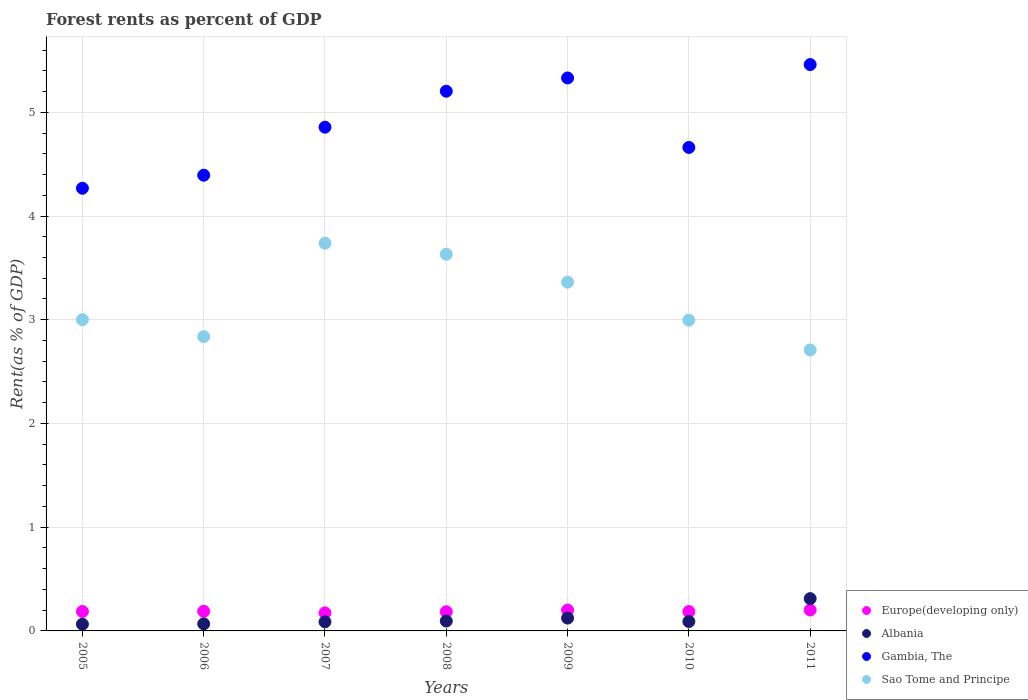How many different coloured dotlines are there?
Offer a terse response. 4. What is the forest rent in Gambia, The in 2007?
Give a very brief answer. 4.86. Across all years, what is the maximum forest rent in Sao Tome and Principe?
Give a very brief answer. 3.74. Across all years, what is the minimum forest rent in Gambia, The?
Make the answer very short. 4.27. What is the total forest rent in Europe(developing only) in the graph?
Your response must be concise. 1.32. What is the difference between the forest rent in Gambia, The in 2008 and that in 2011?
Your response must be concise. -0.26. What is the difference between the forest rent in Gambia, The in 2007 and the forest rent in Sao Tome and Principe in 2008?
Give a very brief answer. 1.22. What is the average forest rent in Sao Tome and Principe per year?
Provide a succinct answer. 3.18. In the year 2010, what is the difference between the forest rent in Gambia, The and forest rent in Sao Tome and Principe?
Keep it short and to the point. 1.67. What is the ratio of the forest rent in Europe(developing only) in 2007 to that in 2008?
Make the answer very short. 0.94. What is the difference between the highest and the second highest forest rent in Europe(developing only)?
Your response must be concise. 0. What is the difference between the highest and the lowest forest rent in Gambia, The?
Provide a short and direct response. 1.19. Is the sum of the forest rent in Europe(developing only) in 2005 and 2010 greater than the maximum forest rent in Sao Tome and Principe across all years?
Offer a terse response. No. Is it the case that in every year, the sum of the forest rent in Albania and forest rent in Europe(developing only)  is greater than the sum of forest rent in Gambia, The and forest rent in Sao Tome and Principe?
Keep it short and to the point. No. Is it the case that in every year, the sum of the forest rent in Gambia, The and forest rent in Europe(developing only)  is greater than the forest rent in Sao Tome and Principe?
Keep it short and to the point. Yes. Does the forest rent in Sao Tome and Principe monotonically increase over the years?
Keep it short and to the point. No. Is the forest rent in Sao Tome and Principe strictly less than the forest rent in Europe(developing only) over the years?
Provide a succinct answer. No. How many dotlines are there?
Make the answer very short. 4. How many years are there in the graph?
Give a very brief answer. 7. Where does the legend appear in the graph?
Give a very brief answer. Bottom right. How many legend labels are there?
Make the answer very short. 4. How are the legend labels stacked?
Make the answer very short. Vertical. What is the title of the graph?
Provide a succinct answer. Forest rents as percent of GDP. What is the label or title of the X-axis?
Provide a short and direct response. Years. What is the label or title of the Y-axis?
Offer a very short reply. Rent(as % of GDP). What is the Rent(as % of GDP) of Europe(developing only) in 2005?
Provide a succinct answer. 0.19. What is the Rent(as % of GDP) of Albania in 2005?
Offer a very short reply. 0.06. What is the Rent(as % of GDP) of Gambia, The in 2005?
Ensure brevity in your answer.  4.27. What is the Rent(as % of GDP) of Sao Tome and Principe in 2005?
Provide a succinct answer. 3. What is the Rent(as % of GDP) in Europe(developing only) in 2006?
Give a very brief answer. 0.19. What is the Rent(as % of GDP) in Albania in 2006?
Ensure brevity in your answer.  0.07. What is the Rent(as % of GDP) of Gambia, The in 2006?
Give a very brief answer. 4.39. What is the Rent(as % of GDP) in Sao Tome and Principe in 2006?
Your answer should be compact. 2.84. What is the Rent(as % of GDP) of Europe(developing only) in 2007?
Provide a short and direct response. 0.17. What is the Rent(as % of GDP) of Albania in 2007?
Make the answer very short. 0.09. What is the Rent(as % of GDP) of Gambia, The in 2007?
Ensure brevity in your answer.  4.86. What is the Rent(as % of GDP) in Sao Tome and Principe in 2007?
Your answer should be compact. 3.74. What is the Rent(as % of GDP) of Europe(developing only) in 2008?
Keep it short and to the point. 0.18. What is the Rent(as % of GDP) in Albania in 2008?
Keep it short and to the point. 0.1. What is the Rent(as % of GDP) in Gambia, The in 2008?
Your response must be concise. 5.2. What is the Rent(as % of GDP) in Sao Tome and Principe in 2008?
Your answer should be very brief. 3.63. What is the Rent(as % of GDP) in Europe(developing only) in 2009?
Ensure brevity in your answer.  0.2. What is the Rent(as % of GDP) of Albania in 2009?
Provide a short and direct response. 0.12. What is the Rent(as % of GDP) of Gambia, The in 2009?
Provide a succinct answer. 5.33. What is the Rent(as % of GDP) of Sao Tome and Principe in 2009?
Make the answer very short. 3.36. What is the Rent(as % of GDP) in Europe(developing only) in 2010?
Provide a succinct answer. 0.19. What is the Rent(as % of GDP) of Albania in 2010?
Provide a short and direct response. 0.09. What is the Rent(as % of GDP) in Gambia, The in 2010?
Offer a very short reply. 4.66. What is the Rent(as % of GDP) of Sao Tome and Principe in 2010?
Keep it short and to the point. 3. What is the Rent(as % of GDP) in Europe(developing only) in 2011?
Your answer should be very brief. 0.2. What is the Rent(as % of GDP) in Albania in 2011?
Offer a very short reply. 0.31. What is the Rent(as % of GDP) of Gambia, The in 2011?
Your answer should be compact. 5.46. What is the Rent(as % of GDP) of Sao Tome and Principe in 2011?
Your answer should be very brief. 2.71. Across all years, what is the maximum Rent(as % of GDP) of Europe(developing only)?
Offer a terse response. 0.2. Across all years, what is the maximum Rent(as % of GDP) in Albania?
Offer a very short reply. 0.31. Across all years, what is the maximum Rent(as % of GDP) of Gambia, The?
Ensure brevity in your answer.  5.46. Across all years, what is the maximum Rent(as % of GDP) of Sao Tome and Principe?
Make the answer very short. 3.74. Across all years, what is the minimum Rent(as % of GDP) of Europe(developing only)?
Offer a terse response. 0.17. Across all years, what is the minimum Rent(as % of GDP) in Albania?
Offer a terse response. 0.06. Across all years, what is the minimum Rent(as % of GDP) in Gambia, The?
Provide a succinct answer. 4.27. Across all years, what is the minimum Rent(as % of GDP) in Sao Tome and Principe?
Provide a short and direct response. 2.71. What is the total Rent(as % of GDP) in Europe(developing only) in the graph?
Your answer should be compact. 1.32. What is the total Rent(as % of GDP) of Albania in the graph?
Offer a very short reply. 0.84. What is the total Rent(as % of GDP) in Gambia, The in the graph?
Your answer should be very brief. 34.17. What is the total Rent(as % of GDP) in Sao Tome and Principe in the graph?
Keep it short and to the point. 22.27. What is the difference between the Rent(as % of GDP) of Europe(developing only) in 2005 and that in 2006?
Offer a terse response. -0. What is the difference between the Rent(as % of GDP) of Albania in 2005 and that in 2006?
Ensure brevity in your answer.  -0. What is the difference between the Rent(as % of GDP) of Gambia, The in 2005 and that in 2006?
Make the answer very short. -0.13. What is the difference between the Rent(as % of GDP) of Sao Tome and Principe in 2005 and that in 2006?
Ensure brevity in your answer.  0.16. What is the difference between the Rent(as % of GDP) in Europe(developing only) in 2005 and that in 2007?
Provide a short and direct response. 0.01. What is the difference between the Rent(as % of GDP) in Albania in 2005 and that in 2007?
Make the answer very short. -0.02. What is the difference between the Rent(as % of GDP) in Gambia, The in 2005 and that in 2007?
Ensure brevity in your answer.  -0.59. What is the difference between the Rent(as % of GDP) in Sao Tome and Principe in 2005 and that in 2007?
Provide a succinct answer. -0.74. What is the difference between the Rent(as % of GDP) in Europe(developing only) in 2005 and that in 2008?
Your response must be concise. 0. What is the difference between the Rent(as % of GDP) of Albania in 2005 and that in 2008?
Your answer should be compact. -0.03. What is the difference between the Rent(as % of GDP) of Gambia, The in 2005 and that in 2008?
Make the answer very short. -0.94. What is the difference between the Rent(as % of GDP) of Sao Tome and Principe in 2005 and that in 2008?
Your answer should be compact. -0.63. What is the difference between the Rent(as % of GDP) of Europe(developing only) in 2005 and that in 2009?
Offer a very short reply. -0.01. What is the difference between the Rent(as % of GDP) of Albania in 2005 and that in 2009?
Provide a succinct answer. -0.06. What is the difference between the Rent(as % of GDP) of Gambia, The in 2005 and that in 2009?
Your answer should be very brief. -1.06. What is the difference between the Rent(as % of GDP) in Sao Tome and Principe in 2005 and that in 2009?
Your answer should be very brief. -0.36. What is the difference between the Rent(as % of GDP) in Europe(developing only) in 2005 and that in 2010?
Your response must be concise. 0. What is the difference between the Rent(as % of GDP) of Albania in 2005 and that in 2010?
Provide a succinct answer. -0.03. What is the difference between the Rent(as % of GDP) in Gambia, The in 2005 and that in 2010?
Provide a short and direct response. -0.39. What is the difference between the Rent(as % of GDP) in Sao Tome and Principe in 2005 and that in 2010?
Give a very brief answer. 0.01. What is the difference between the Rent(as % of GDP) of Europe(developing only) in 2005 and that in 2011?
Provide a short and direct response. -0.01. What is the difference between the Rent(as % of GDP) in Albania in 2005 and that in 2011?
Make the answer very short. -0.25. What is the difference between the Rent(as % of GDP) of Gambia, The in 2005 and that in 2011?
Provide a short and direct response. -1.19. What is the difference between the Rent(as % of GDP) in Sao Tome and Principe in 2005 and that in 2011?
Offer a terse response. 0.29. What is the difference between the Rent(as % of GDP) in Europe(developing only) in 2006 and that in 2007?
Your answer should be very brief. 0.02. What is the difference between the Rent(as % of GDP) of Albania in 2006 and that in 2007?
Give a very brief answer. -0.02. What is the difference between the Rent(as % of GDP) in Gambia, The in 2006 and that in 2007?
Make the answer very short. -0.46. What is the difference between the Rent(as % of GDP) in Sao Tome and Principe in 2006 and that in 2007?
Make the answer very short. -0.9. What is the difference between the Rent(as % of GDP) in Europe(developing only) in 2006 and that in 2008?
Offer a terse response. 0. What is the difference between the Rent(as % of GDP) in Albania in 2006 and that in 2008?
Give a very brief answer. -0.03. What is the difference between the Rent(as % of GDP) in Gambia, The in 2006 and that in 2008?
Ensure brevity in your answer.  -0.81. What is the difference between the Rent(as % of GDP) of Sao Tome and Principe in 2006 and that in 2008?
Offer a very short reply. -0.79. What is the difference between the Rent(as % of GDP) in Europe(developing only) in 2006 and that in 2009?
Offer a terse response. -0.01. What is the difference between the Rent(as % of GDP) in Albania in 2006 and that in 2009?
Offer a terse response. -0.06. What is the difference between the Rent(as % of GDP) in Gambia, The in 2006 and that in 2009?
Offer a terse response. -0.94. What is the difference between the Rent(as % of GDP) in Sao Tome and Principe in 2006 and that in 2009?
Your answer should be very brief. -0.52. What is the difference between the Rent(as % of GDP) in Europe(developing only) in 2006 and that in 2010?
Ensure brevity in your answer.  0. What is the difference between the Rent(as % of GDP) of Albania in 2006 and that in 2010?
Ensure brevity in your answer.  -0.02. What is the difference between the Rent(as % of GDP) of Gambia, The in 2006 and that in 2010?
Your answer should be very brief. -0.27. What is the difference between the Rent(as % of GDP) of Sao Tome and Principe in 2006 and that in 2010?
Your answer should be compact. -0.16. What is the difference between the Rent(as % of GDP) of Europe(developing only) in 2006 and that in 2011?
Keep it short and to the point. -0.01. What is the difference between the Rent(as % of GDP) of Albania in 2006 and that in 2011?
Your answer should be compact. -0.24. What is the difference between the Rent(as % of GDP) in Gambia, The in 2006 and that in 2011?
Your response must be concise. -1.07. What is the difference between the Rent(as % of GDP) in Sao Tome and Principe in 2006 and that in 2011?
Provide a short and direct response. 0.13. What is the difference between the Rent(as % of GDP) in Europe(developing only) in 2007 and that in 2008?
Offer a terse response. -0.01. What is the difference between the Rent(as % of GDP) of Albania in 2007 and that in 2008?
Give a very brief answer. -0.01. What is the difference between the Rent(as % of GDP) in Gambia, The in 2007 and that in 2008?
Give a very brief answer. -0.35. What is the difference between the Rent(as % of GDP) of Sao Tome and Principe in 2007 and that in 2008?
Your response must be concise. 0.11. What is the difference between the Rent(as % of GDP) of Europe(developing only) in 2007 and that in 2009?
Offer a very short reply. -0.03. What is the difference between the Rent(as % of GDP) in Albania in 2007 and that in 2009?
Your answer should be very brief. -0.04. What is the difference between the Rent(as % of GDP) in Gambia, The in 2007 and that in 2009?
Make the answer very short. -0.47. What is the difference between the Rent(as % of GDP) in Sao Tome and Principe in 2007 and that in 2009?
Give a very brief answer. 0.38. What is the difference between the Rent(as % of GDP) in Europe(developing only) in 2007 and that in 2010?
Offer a very short reply. -0.01. What is the difference between the Rent(as % of GDP) in Albania in 2007 and that in 2010?
Give a very brief answer. -0. What is the difference between the Rent(as % of GDP) of Gambia, The in 2007 and that in 2010?
Offer a very short reply. 0.2. What is the difference between the Rent(as % of GDP) of Sao Tome and Principe in 2007 and that in 2010?
Provide a short and direct response. 0.74. What is the difference between the Rent(as % of GDP) in Europe(developing only) in 2007 and that in 2011?
Make the answer very short. -0.03. What is the difference between the Rent(as % of GDP) of Albania in 2007 and that in 2011?
Offer a very short reply. -0.22. What is the difference between the Rent(as % of GDP) of Gambia, The in 2007 and that in 2011?
Offer a terse response. -0.6. What is the difference between the Rent(as % of GDP) of Sao Tome and Principe in 2007 and that in 2011?
Give a very brief answer. 1.03. What is the difference between the Rent(as % of GDP) in Europe(developing only) in 2008 and that in 2009?
Offer a very short reply. -0.02. What is the difference between the Rent(as % of GDP) in Albania in 2008 and that in 2009?
Give a very brief answer. -0.03. What is the difference between the Rent(as % of GDP) of Gambia, The in 2008 and that in 2009?
Make the answer very short. -0.13. What is the difference between the Rent(as % of GDP) in Sao Tome and Principe in 2008 and that in 2009?
Offer a terse response. 0.27. What is the difference between the Rent(as % of GDP) in Europe(developing only) in 2008 and that in 2010?
Give a very brief answer. -0. What is the difference between the Rent(as % of GDP) of Albania in 2008 and that in 2010?
Offer a very short reply. 0. What is the difference between the Rent(as % of GDP) of Gambia, The in 2008 and that in 2010?
Your answer should be very brief. 0.54. What is the difference between the Rent(as % of GDP) of Sao Tome and Principe in 2008 and that in 2010?
Keep it short and to the point. 0.64. What is the difference between the Rent(as % of GDP) of Europe(developing only) in 2008 and that in 2011?
Provide a short and direct response. -0.02. What is the difference between the Rent(as % of GDP) in Albania in 2008 and that in 2011?
Give a very brief answer. -0.22. What is the difference between the Rent(as % of GDP) in Gambia, The in 2008 and that in 2011?
Provide a short and direct response. -0.26. What is the difference between the Rent(as % of GDP) of Sao Tome and Principe in 2008 and that in 2011?
Keep it short and to the point. 0.92. What is the difference between the Rent(as % of GDP) of Europe(developing only) in 2009 and that in 2010?
Keep it short and to the point. 0.01. What is the difference between the Rent(as % of GDP) of Albania in 2009 and that in 2010?
Your answer should be compact. 0.03. What is the difference between the Rent(as % of GDP) in Gambia, The in 2009 and that in 2010?
Ensure brevity in your answer.  0.67. What is the difference between the Rent(as % of GDP) of Sao Tome and Principe in 2009 and that in 2010?
Offer a terse response. 0.37. What is the difference between the Rent(as % of GDP) of Europe(developing only) in 2009 and that in 2011?
Make the answer very short. -0. What is the difference between the Rent(as % of GDP) of Albania in 2009 and that in 2011?
Your answer should be compact. -0.19. What is the difference between the Rent(as % of GDP) in Gambia, The in 2009 and that in 2011?
Your answer should be compact. -0.13. What is the difference between the Rent(as % of GDP) in Sao Tome and Principe in 2009 and that in 2011?
Offer a very short reply. 0.65. What is the difference between the Rent(as % of GDP) in Europe(developing only) in 2010 and that in 2011?
Your answer should be very brief. -0.02. What is the difference between the Rent(as % of GDP) of Albania in 2010 and that in 2011?
Make the answer very short. -0.22. What is the difference between the Rent(as % of GDP) in Gambia, The in 2010 and that in 2011?
Offer a terse response. -0.8. What is the difference between the Rent(as % of GDP) of Sao Tome and Principe in 2010 and that in 2011?
Provide a succinct answer. 0.29. What is the difference between the Rent(as % of GDP) of Europe(developing only) in 2005 and the Rent(as % of GDP) of Albania in 2006?
Your answer should be compact. 0.12. What is the difference between the Rent(as % of GDP) of Europe(developing only) in 2005 and the Rent(as % of GDP) of Gambia, The in 2006?
Provide a succinct answer. -4.21. What is the difference between the Rent(as % of GDP) of Europe(developing only) in 2005 and the Rent(as % of GDP) of Sao Tome and Principe in 2006?
Offer a terse response. -2.65. What is the difference between the Rent(as % of GDP) of Albania in 2005 and the Rent(as % of GDP) of Gambia, The in 2006?
Make the answer very short. -4.33. What is the difference between the Rent(as % of GDP) of Albania in 2005 and the Rent(as % of GDP) of Sao Tome and Principe in 2006?
Give a very brief answer. -2.77. What is the difference between the Rent(as % of GDP) of Gambia, The in 2005 and the Rent(as % of GDP) of Sao Tome and Principe in 2006?
Your response must be concise. 1.43. What is the difference between the Rent(as % of GDP) in Europe(developing only) in 2005 and the Rent(as % of GDP) in Albania in 2007?
Your answer should be very brief. 0.1. What is the difference between the Rent(as % of GDP) in Europe(developing only) in 2005 and the Rent(as % of GDP) in Gambia, The in 2007?
Your answer should be very brief. -4.67. What is the difference between the Rent(as % of GDP) in Europe(developing only) in 2005 and the Rent(as % of GDP) in Sao Tome and Principe in 2007?
Ensure brevity in your answer.  -3.55. What is the difference between the Rent(as % of GDP) of Albania in 2005 and the Rent(as % of GDP) of Gambia, The in 2007?
Provide a succinct answer. -4.79. What is the difference between the Rent(as % of GDP) of Albania in 2005 and the Rent(as % of GDP) of Sao Tome and Principe in 2007?
Your response must be concise. -3.67. What is the difference between the Rent(as % of GDP) in Gambia, The in 2005 and the Rent(as % of GDP) in Sao Tome and Principe in 2007?
Make the answer very short. 0.53. What is the difference between the Rent(as % of GDP) in Europe(developing only) in 2005 and the Rent(as % of GDP) in Albania in 2008?
Make the answer very short. 0.09. What is the difference between the Rent(as % of GDP) of Europe(developing only) in 2005 and the Rent(as % of GDP) of Gambia, The in 2008?
Offer a very short reply. -5.02. What is the difference between the Rent(as % of GDP) of Europe(developing only) in 2005 and the Rent(as % of GDP) of Sao Tome and Principe in 2008?
Offer a very short reply. -3.44. What is the difference between the Rent(as % of GDP) in Albania in 2005 and the Rent(as % of GDP) in Gambia, The in 2008?
Your answer should be compact. -5.14. What is the difference between the Rent(as % of GDP) of Albania in 2005 and the Rent(as % of GDP) of Sao Tome and Principe in 2008?
Make the answer very short. -3.57. What is the difference between the Rent(as % of GDP) in Gambia, The in 2005 and the Rent(as % of GDP) in Sao Tome and Principe in 2008?
Provide a succinct answer. 0.64. What is the difference between the Rent(as % of GDP) of Europe(developing only) in 2005 and the Rent(as % of GDP) of Albania in 2009?
Your answer should be very brief. 0.06. What is the difference between the Rent(as % of GDP) in Europe(developing only) in 2005 and the Rent(as % of GDP) in Gambia, The in 2009?
Give a very brief answer. -5.14. What is the difference between the Rent(as % of GDP) in Europe(developing only) in 2005 and the Rent(as % of GDP) in Sao Tome and Principe in 2009?
Offer a very short reply. -3.17. What is the difference between the Rent(as % of GDP) in Albania in 2005 and the Rent(as % of GDP) in Gambia, The in 2009?
Provide a succinct answer. -5.27. What is the difference between the Rent(as % of GDP) of Albania in 2005 and the Rent(as % of GDP) of Sao Tome and Principe in 2009?
Give a very brief answer. -3.3. What is the difference between the Rent(as % of GDP) in Gambia, The in 2005 and the Rent(as % of GDP) in Sao Tome and Principe in 2009?
Offer a terse response. 0.91. What is the difference between the Rent(as % of GDP) in Europe(developing only) in 2005 and the Rent(as % of GDP) in Albania in 2010?
Keep it short and to the point. 0.1. What is the difference between the Rent(as % of GDP) of Europe(developing only) in 2005 and the Rent(as % of GDP) of Gambia, The in 2010?
Provide a succinct answer. -4.47. What is the difference between the Rent(as % of GDP) in Europe(developing only) in 2005 and the Rent(as % of GDP) in Sao Tome and Principe in 2010?
Keep it short and to the point. -2.81. What is the difference between the Rent(as % of GDP) in Albania in 2005 and the Rent(as % of GDP) in Gambia, The in 2010?
Your response must be concise. -4.6. What is the difference between the Rent(as % of GDP) in Albania in 2005 and the Rent(as % of GDP) in Sao Tome and Principe in 2010?
Provide a succinct answer. -2.93. What is the difference between the Rent(as % of GDP) of Gambia, The in 2005 and the Rent(as % of GDP) of Sao Tome and Principe in 2010?
Provide a short and direct response. 1.27. What is the difference between the Rent(as % of GDP) of Europe(developing only) in 2005 and the Rent(as % of GDP) of Albania in 2011?
Make the answer very short. -0.12. What is the difference between the Rent(as % of GDP) of Europe(developing only) in 2005 and the Rent(as % of GDP) of Gambia, The in 2011?
Provide a short and direct response. -5.27. What is the difference between the Rent(as % of GDP) of Europe(developing only) in 2005 and the Rent(as % of GDP) of Sao Tome and Principe in 2011?
Provide a succinct answer. -2.52. What is the difference between the Rent(as % of GDP) of Albania in 2005 and the Rent(as % of GDP) of Gambia, The in 2011?
Your response must be concise. -5.4. What is the difference between the Rent(as % of GDP) in Albania in 2005 and the Rent(as % of GDP) in Sao Tome and Principe in 2011?
Keep it short and to the point. -2.64. What is the difference between the Rent(as % of GDP) of Gambia, The in 2005 and the Rent(as % of GDP) of Sao Tome and Principe in 2011?
Give a very brief answer. 1.56. What is the difference between the Rent(as % of GDP) in Europe(developing only) in 2006 and the Rent(as % of GDP) in Albania in 2007?
Keep it short and to the point. 0.1. What is the difference between the Rent(as % of GDP) of Europe(developing only) in 2006 and the Rent(as % of GDP) of Gambia, The in 2007?
Provide a succinct answer. -4.67. What is the difference between the Rent(as % of GDP) in Europe(developing only) in 2006 and the Rent(as % of GDP) in Sao Tome and Principe in 2007?
Your response must be concise. -3.55. What is the difference between the Rent(as % of GDP) of Albania in 2006 and the Rent(as % of GDP) of Gambia, The in 2007?
Provide a short and direct response. -4.79. What is the difference between the Rent(as % of GDP) of Albania in 2006 and the Rent(as % of GDP) of Sao Tome and Principe in 2007?
Provide a short and direct response. -3.67. What is the difference between the Rent(as % of GDP) in Gambia, The in 2006 and the Rent(as % of GDP) in Sao Tome and Principe in 2007?
Your answer should be very brief. 0.66. What is the difference between the Rent(as % of GDP) in Europe(developing only) in 2006 and the Rent(as % of GDP) in Albania in 2008?
Provide a succinct answer. 0.09. What is the difference between the Rent(as % of GDP) of Europe(developing only) in 2006 and the Rent(as % of GDP) of Gambia, The in 2008?
Offer a very short reply. -5.01. What is the difference between the Rent(as % of GDP) of Europe(developing only) in 2006 and the Rent(as % of GDP) of Sao Tome and Principe in 2008?
Ensure brevity in your answer.  -3.44. What is the difference between the Rent(as % of GDP) in Albania in 2006 and the Rent(as % of GDP) in Gambia, The in 2008?
Make the answer very short. -5.14. What is the difference between the Rent(as % of GDP) in Albania in 2006 and the Rent(as % of GDP) in Sao Tome and Principe in 2008?
Offer a very short reply. -3.56. What is the difference between the Rent(as % of GDP) of Gambia, The in 2006 and the Rent(as % of GDP) of Sao Tome and Principe in 2008?
Provide a succinct answer. 0.76. What is the difference between the Rent(as % of GDP) of Europe(developing only) in 2006 and the Rent(as % of GDP) of Albania in 2009?
Provide a succinct answer. 0.07. What is the difference between the Rent(as % of GDP) in Europe(developing only) in 2006 and the Rent(as % of GDP) in Gambia, The in 2009?
Offer a very short reply. -5.14. What is the difference between the Rent(as % of GDP) of Europe(developing only) in 2006 and the Rent(as % of GDP) of Sao Tome and Principe in 2009?
Provide a short and direct response. -3.17. What is the difference between the Rent(as % of GDP) of Albania in 2006 and the Rent(as % of GDP) of Gambia, The in 2009?
Your answer should be compact. -5.26. What is the difference between the Rent(as % of GDP) of Albania in 2006 and the Rent(as % of GDP) of Sao Tome and Principe in 2009?
Provide a succinct answer. -3.29. What is the difference between the Rent(as % of GDP) in Gambia, The in 2006 and the Rent(as % of GDP) in Sao Tome and Principe in 2009?
Your response must be concise. 1.03. What is the difference between the Rent(as % of GDP) in Europe(developing only) in 2006 and the Rent(as % of GDP) in Albania in 2010?
Keep it short and to the point. 0.1. What is the difference between the Rent(as % of GDP) of Europe(developing only) in 2006 and the Rent(as % of GDP) of Gambia, The in 2010?
Give a very brief answer. -4.47. What is the difference between the Rent(as % of GDP) in Europe(developing only) in 2006 and the Rent(as % of GDP) in Sao Tome and Principe in 2010?
Your answer should be compact. -2.81. What is the difference between the Rent(as % of GDP) in Albania in 2006 and the Rent(as % of GDP) in Gambia, The in 2010?
Offer a terse response. -4.59. What is the difference between the Rent(as % of GDP) in Albania in 2006 and the Rent(as % of GDP) in Sao Tome and Principe in 2010?
Ensure brevity in your answer.  -2.93. What is the difference between the Rent(as % of GDP) in Gambia, The in 2006 and the Rent(as % of GDP) in Sao Tome and Principe in 2010?
Give a very brief answer. 1.4. What is the difference between the Rent(as % of GDP) of Europe(developing only) in 2006 and the Rent(as % of GDP) of Albania in 2011?
Offer a very short reply. -0.12. What is the difference between the Rent(as % of GDP) in Europe(developing only) in 2006 and the Rent(as % of GDP) in Gambia, The in 2011?
Keep it short and to the point. -5.27. What is the difference between the Rent(as % of GDP) in Europe(developing only) in 2006 and the Rent(as % of GDP) in Sao Tome and Principe in 2011?
Offer a very short reply. -2.52. What is the difference between the Rent(as % of GDP) of Albania in 2006 and the Rent(as % of GDP) of Gambia, The in 2011?
Your answer should be compact. -5.39. What is the difference between the Rent(as % of GDP) of Albania in 2006 and the Rent(as % of GDP) of Sao Tome and Principe in 2011?
Provide a succinct answer. -2.64. What is the difference between the Rent(as % of GDP) of Gambia, The in 2006 and the Rent(as % of GDP) of Sao Tome and Principe in 2011?
Your answer should be very brief. 1.68. What is the difference between the Rent(as % of GDP) of Europe(developing only) in 2007 and the Rent(as % of GDP) of Albania in 2008?
Provide a succinct answer. 0.08. What is the difference between the Rent(as % of GDP) of Europe(developing only) in 2007 and the Rent(as % of GDP) of Gambia, The in 2008?
Keep it short and to the point. -5.03. What is the difference between the Rent(as % of GDP) of Europe(developing only) in 2007 and the Rent(as % of GDP) of Sao Tome and Principe in 2008?
Provide a succinct answer. -3.46. What is the difference between the Rent(as % of GDP) of Albania in 2007 and the Rent(as % of GDP) of Gambia, The in 2008?
Offer a terse response. -5.12. What is the difference between the Rent(as % of GDP) of Albania in 2007 and the Rent(as % of GDP) of Sao Tome and Principe in 2008?
Offer a terse response. -3.54. What is the difference between the Rent(as % of GDP) of Gambia, The in 2007 and the Rent(as % of GDP) of Sao Tome and Principe in 2008?
Your response must be concise. 1.22. What is the difference between the Rent(as % of GDP) in Europe(developing only) in 2007 and the Rent(as % of GDP) in Albania in 2009?
Your response must be concise. 0.05. What is the difference between the Rent(as % of GDP) in Europe(developing only) in 2007 and the Rent(as % of GDP) in Gambia, The in 2009?
Provide a short and direct response. -5.16. What is the difference between the Rent(as % of GDP) in Europe(developing only) in 2007 and the Rent(as % of GDP) in Sao Tome and Principe in 2009?
Your response must be concise. -3.19. What is the difference between the Rent(as % of GDP) in Albania in 2007 and the Rent(as % of GDP) in Gambia, The in 2009?
Offer a very short reply. -5.24. What is the difference between the Rent(as % of GDP) of Albania in 2007 and the Rent(as % of GDP) of Sao Tome and Principe in 2009?
Offer a very short reply. -3.27. What is the difference between the Rent(as % of GDP) in Gambia, The in 2007 and the Rent(as % of GDP) in Sao Tome and Principe in 2009?
Your response must be concise. 1.49. What is the difference between the Rent(as % of GDP) in Europe(developing only) in 2007 and the Rent(as % of GDP) in Albania in 2010?
Offer a very short reply. 0.08. What is the difference between the Rent(as % of GDP) of Europe(developing only) in 2007 and the Rent(as % of GDP) of Gambia, The in 2010?
Offer a terse response. -4.49. What is the difference between the Rent(as % of GDP) of Europe(developing only) in 2007 and the Rent(as % of GDP) of Sao Tome and Principe in 2010?
Provide a short and direct response. -2.82. What is the difference between the Rent(as % of GDP) in Albania in 2007 and the Rent(as % of GDP) in Gambia, The in 2010?
Offer a terse response. -4.57. What is the difference between the Rent(as % of GDP) in Albania in 2007 and the Rent(as % of GDP) in Sao Tome and Principe in 2010?
Provide a short and direct response. -2.91. What is the difference between the Rent(as % of GDP) of Gambia, The in 2007 and the Rent(as % of GDP) of Sao Tome and Principe in 2010?
Provide a short and direct response. 1.86. What is the difference between the Rent(as % of GDP) of Europe(developing only) in 2007 and the Rent(as % of GDP) of Albania in 2011?
Your response must be concise. -0.14. What is the difference between the Rent(as % of GDP) in Europe(developing only) in 2007 and the Rent(as % of GDP) in Gambia, The in 2011?
Your answer should be compact. -5.29. What is the difference between the Rent(as % of GDP) in Europe(developing only) in 2007 and the Rent(as % of GDP) in Sao Tome and Principe in 2011?
Provide a succinct answer. -2.53. What is the difference between the Rent(as % of GDP) of Albania in 2007 and the Rent(as % of GDP) of Gambia, The in 2011?
Provide a short and direct response. -5.37. What is the difference between the Rent(as % of GDP) in Albania in 2007 and the Rent(as % of GDP) in Sao Tome and Principe in 2011?
Your response must be concise. -2.62. What is the difference between the Rent(as % of GDP) of Gambia, The in 2007 and the Rent(as % of GDP) of Sao Tome and Principe in 2011?
Your response must be concise. 2.15. What is the difference between the Rent(as % of GDP) in Europe(developing only) in 2008 and the Rent(as % of GDP) in Albania in 2009?
Ensure brevity in your answer.  0.06. What is the difference between the Rent(as % of GDP) in Europe(developing only) in 2008 and the Rent(as % of GDP) in Gambia, The in 2009?
Your response must be concise. -5.15. What is the difference between the Rent(as % of GDP) in Europe(developing only) in 2008 and the Rent(as % of GDP) in Sao Tome and Principe in 2009?
Ensure brevity in your answer.  -3.18. What is the difference between the Rent(as % of GDP) of Albania in 2008 and the Rent(as % of GDP) of Gambia, The in 2009?
Your answer should be compact. -5.24. What is the difference between the Rent(as % of GDP) in Albania in 2008 and the Rent(as % of GDP) in Sao Tome and Principe in 2009?
Your response must be concise. -3.27. What is the difference between the Rent(as % of GDP) in Gambia, The in 2008 and the Rent(as % of GDP) in Sao Tome and Principe in 2009?
Keep it short and to the point. 1.84. What is the difference between the Rent(as % of GDP) of Europe(developing only) in 2008 and the Rent(as % of GDP) of Albania in 2010?
Make the answer very short. 0.09. What is the difference between the Rent(as % of GDP) in Europe(developing only) in 2008 and the Rent(as % of GDP) in Gambia, The in 2010?
Make the answer very short. -4.48. What is the difference between the Rent(as % of GDP) in Europe(developing only) in 2008 and the Rent(as % of GDP) in Sao Tome and Principe in 2010?
Make the answer very short. -2.81. What is the difference between the Rent(as % of GDP) of Albania in 2008 and the Rent(as % of GDP) of Gambia, The in 2010?
Your answer should be compact. -4.57. What is the difference between the Rent(as % of GDP) of Albania in 2008 and the Rent(as % of GDP) of Sao Tome and Principe in 2010?
Give a very brief answer. -2.9. What is the difference between the Rent(as % of GDP) in Gambia, The in 2008 and the Rent(as % of GDP) in Sao Tome and Principe in 2010?
Ensure brevity in your answer.  2.21. What is the difference between the Rent(as % of GDP) of Europe(developing only) in 2008 and the Rent(as % of GDP) of Albania in 2011?
Your response must be concise. -0.13. What is the difference between the Rent(as % of GDP) in Europe(developing only) in 2008 and the Rent(as % of GDP) in Gambia, The in 2011?
Ensure brevity in your answer.  -5.28. What is the difference between the Rent(as % of GDP) in Europe(developing only) in 2008 and the Rent(as % of GDP) in Sao Tome and Principe in 2011?
Keep it short and to the point. -2.52. What is the difference between the Rent(as % of GDP) in Albania in 2008 and the Rent(as % of GDP) in Gambia, The in 2011?
Offer a very short reply. -5.37. What is the difference between the Rent(as % of GDP) of Albania in 2008 and the Rent(as % of GDP) of Sao Tome and Principe in 2011?
Offer a very short reply. -2.61. What is the difference between the Rent(as % of GDP) of Gambia, The in 2008 and the Rent(as % of GDP) of Sao Tome and Principe in 2011?
Offer a very short reply. 2.49. What is the difference between the Rent(as % of GDP) in Europe(developing only) in 2009 and the Rent(as % of GDP) in Albania in 2010?
Offer a terse response. 0.11. What is the difference between the Rent(as % of GDP) of Europe(developing only) in 2009 and the Rent(as % of GDP) of Gambia, The in 2010?
Give a very brief answer. -4.46. What is the difference between the Rent(as % of GDP) in Europe(developing only) in 2009 and the Rent(as % of GDP) in Sao Tome and Principe in 2010?
Keep it short and to the point. -2.79. What is the difference between the Rent(as % of GDP) in Albania in 2009 and the Rent(as % of GDP) in Gambia, The in 2010?
Ensure brevity in your answer.  -4.54. What is the difference between the Rent(as % of GDP) in Albania in 2009 and the Rent(as % of GDP) in Sao Tome and Principe in 2010?
Keep it short and to the point. -2.87. What is the difference between the Rent(as % of GDP) of Gambia, The in 2009 and the Rent(as % of GDP) of Sao Tome and Principe in 2010?
Provide a short and direct response. 2.34. What is the difference between the Rent(as % of GDP) of Europe(developing only) in 2009 and the Rent(as % of GDP) of Albania in 2011?
Your answer should be compact. -0.11. What is the difference between the Rent(as % of GDP) of Europe(developing only) in 2009 and the Rent(as % of GDP) of Gambia, The in 2011?
Provide a succinct answer. -5.26. What is the difference between the Rent(as % of GDP) in Europe(developing only) in 2009 and the Rent(as % of GDP) in Sao Tome and Principe in 2011?
Offer a terse response. -2.51. What is the difference between the Rent(as % of GDP) in Albania in 2009 and the Rent(as % of GDP) in Gambia, The in 2011?
Provide a succinct answer. -5.34. What is the difference between the Rent(as % of GDP) in Albania in 2009 and the Rent(as % of GDP) in Sao Tome and Principe in 2011?
Provide a short and direct response. -2.59. What is the difference between the Rent(as % of GDP) of Gambia, The in 2009 and the Rent(as % of GDP) of Sao Tome and Principe in 2011?
Your answer should be compact. 2.62. What is the difference between the Rent(as % of GDP) of Europe(developing only) in 2010 and the Rent(as % of GDP) of Albania in 2011?
Your response must be concise. -0.12. What is the difference between the Rent(as % of GDP) of Europe(developing only) in 2010 and the Rent(as % of GDP) of Gambia, The in 2011?
Make the answer very short. -5.27. What is the difference between the Rent(as % of GDP) in Europe(developing only) in 2010 and the Rent(as % of GDP) in Sao Tome and Principe in 2011?
Offer a very short reply. -2.52. What is the difference between the Rent(as % of GDP) of Albania in 2010 and the Rent(as % of GDP) of Gambia, The in 2011?
Provide a short and direct response. -5.37. What is the difference between the Rent(as % of GDP) in Albania in 2010 and the Rent(as % of GDP) in Sao Tome and Principe in 2011?
Keep it short and to the point. -2.62. What is the difference between the Rent(as % of GDP) in Gambia, The in 2010 and the Rent(as % of GDP) in Sao Tome and Principe in 2011?
Keep it short and to the point. 1.95. What is the average Rent(as % of GDP) in Europe(developing only) per year?
Keep it short and to the point. 0.19. What is the average Rent(as % of GDP) in Albania per year?
Offer a very short reply. 0.12. What is the average Rent(as % of GDP) in Gambia, The per year?
Provide a short and direct response. 4.88. What is the average Rent(as % of GDP) in Sao Tome and Principe per year?
Your answer should be very brief. 3.18. In the year 2005, what is the difference between the Rent(as % of GDP) of Europe(developing only) and Rent(as % of GDP) of Albania?
Make the answer very short. 0.12. In the year 2005, what is the difference between the Rent(as % of GDP) of Europe(developing only) and Rent(as % of GDP) of Gambia, The?
Your answer should be compact. -4.08. In the year 2005, what is the difference between the Rent(as % of GDP) in Europe(developing only) and Rent(as % of GDP) in Sao Tome and Principe?
Give a very brief answer. -2.81. In the year 2005, what is the difference between the Rent(as % of GDP) of Albania and Rent(as % of GDP) of Gambia, The?
Your answer should be compact. -4.2. In the year 2005, what is the difference between the Rent(as % of GDP) of Albania and Rent(as % of GDP) of Sao Tome and Principe?
Provide a short and direct response. -2.94. In the year 2005, what is the difference between the Rent(as % of GDP) of Gambia, The and Rent(as % of GDP) of Sao Tome and Principe?
Ensure brevity in your answer.  1.27. In the year 2006, what is the difference between the Rent(as % of GDP) of Europe(developing only) and Rent(as % of GDP) of Albania?
Offer a terse response. 0.12. In the year 2006, what is the difference between the Rent(as % of GDP) of Europe(developing only) and Rent(as % of GDP) of Gambia, The?
Your answer should be compact. -4.2. In the year 2006, what is the difference between the Rent(as % of GDP) in Europe(developing only) and Rent(as % of GDP) in Sao Tome and Principe?
Offer a very short reply. -2.65. In the year 2006, what is the difference between the Rent(as % of GDP) of Albania and Rent(as % of GDP) of Gambia, The?
Provide a succinct answer. -4.33. In the year 2006, what is the difference between the Rent(as % of GDP) of Albania and Rent(as % of GDP) of Sao Tome and Principe?
Provide a short and direct response. -2.77. In the year 2006, what is the difference between the Rent(as % of GDP) of Gambia, The and Rent(as % of GDP) of Sao Tome and Principe?
Offer a terse response. 1.56. In the year 2007, what is the difference between the Rent(as % of GDP) in Europe(developing only) and Rent(as % of GDP) in Albania?
Offer a terse response. 0.09. In the year 2007, what is the difference between the Rent(as % of GDP) of Europe(developing only) and Rent(as % of GDP) of Gambia, The?
Your answer should be compact. -4.68. In the year 2007, what is the difference between the Rent(as % of GDP) in Europe(developing only) and Rent(as % of GDP) in Sao Tome and Principe?
Offer a very short reply. -3.56. In the year 2007, what is the difference between the Rent(as % of GDP) of Albania and Rent(as % of GDP) of Gambia, The?
Your answer should be compact. -4.77. In the year 2007, what is the difference between the Rent(as % of GDP) in Albania and Rent(as % of GDP) in Sao Tome and Principe?
Provide a succinct answer. -3.65. In the year 2007, what is the difference between the Rent(as % of GDP) in Gambia, The and Rent(as % of GDP) in Sao Tome and Principe?
Your answer should be very brief. 1.12. In the year 2008, what is the difference between the Rent(as % of GDP) in Europe(developing only) and Rent(as % of GDP) in Albania?
Your answer should be very brief. 0.09. In the year 2008, what is the difference between the Rent(as % of GDP) of Europe(developing only) and Rent(as % of GDP) of Gambia, The?
Your answer should be compact. -5.02. In the year 2008, what is the difference between the Rent(as % of GDP) in Europe(developing only) and Rent(as % of GDP) in Sao Tome and Principe?
Offer a terse response. -3.45. In the year 2008, what is the difference between the Rent(as % of GDP) in Albania and Rent(as % of GDP) in Gambia, The?
Offer a terse response. -5.11. In the year 2008, what is the difference between the Rent(as % of GDP) of Albania and Rent(as % of GDP) of Sao Tome and Principe?
Your response must be concise. -3.54. In the year 2008, what is the difference between the Rent(as % of GDP) of Gambia, The and Rent(as % of GDP) of Sao Tome and Principe?
Provide a succinct answer. 1.57. In the year 2009, what is the difference between the Rent(as % of GDP) in Europe(developing only) and Rent(as % of GDP) in Albania?
Keep it short and to the point. 0.08. In the year 2009, what is the difference between the Rent(as % of GDP) in Europe(developing only) and Rent(as % of GDP) in Gambia, The?
Provide a succinct answer. -5.13. In the year 2009, what is the difference between the Rent(as % of GDP) of Europe(developing only) and Rent(as % of GDP) of Sao Tome and Principe?
Make the answer very short. -3.16. In the year 2009, what is the difference between the Rent(as % of GDP) in Albania and Rent(as % of GDP) in Gambia, The?
Offer a very short reply. -5.21. In the year 2009, what is the difference between the Rent(as % of GDP) of Albania and Rent(as % of GDP) of Sao Tome and Principe?
Offer a terse response. -3.24. In the year 2009, what is the difference between the Rent(as % of GDP) of Gambia, The and Rent(as % of GDP) of Sao Tome and Principe?
Your answer should be compact. 1.97. In the year 2010, what is the difference between the Rent(as % of GDP) in Europe(developing only) and Rent(as % of GDP) in Albania?
Offer a terse response. 0.1. In the year 2010, what is the difference between the Rent(as % of GDP) of Europe(developing only) and Rent(as % of GDP) of Gambia, The?
Your response must be concise. -4.47. In the year 2010, what is the difference between the Rent(as % of GDP) in Europe(developing only) and Rent(as % of GDP) in Sao Tome and Principe?
Give a very brief answer. -2.81. In the year 2010, what is the difference between the Rent(as % of GDP) of Albania and Rent(as % of GDP) of Gambia, The?
Offer a terse response. -4.57. In the year 2010, what is the difference between the Rent(as % of GDP) of Albania and Rent(as % of GDP) of Sao Tome and Principe?
Ensure brevity in your answer.  -2.9. In the year 2010, what is the difference between the Rent(as % of GDP) of Gambia, The and Rent(as % of GDP) of Sao Tome and Principe?
Provide a short and direct response. 1.67. In the year 2011, what is the difference between the Rent(as % of GDP) of Europe(developing only) and Rent(as % of GDP) of Albania?
Give a very brief answer. -0.11. In the year 2011, what is the difference between the Rent(as % of GDP) of Europe(developing only) and Rent(as % of GDP) of Gambia, The?
Give a very brief answer. -5.26. In the year 2011, what is the difference between the Rent(as % of GDP) of Europe(developing only) and Rent(as % of GDP) of Sao Tome and Principe?
Provide a short and direct response. -2.51. In the year 2011, what is the difference between the Rent(as % of GDP) of Albania and Rent(as % of GDP) of Gambia, The?
Ensure brevity in your answer.  -5.15. In the year 2011, what is the difference between the Rent(as % of GDP) in Albania and Rent(as % of GDP) in Sao Tome and Principe?
Provide a succinct answer. -2.4. In the year 2011, what is the difference between the Rent(as % of GDP) of Gambia, The and Rent(as % of GDP) of Sao Tome and Principe?
Provide a succinct answer. 2.75. What is the ratio of the Rent(as % of GDP) in Albania in 2005 to that in 2006?
Provide a succinct answer. 0.95. What is the ratio of the Rent(as % of GDP) in Gambia, The in 2005 to that in 2006?
Offer a very short reply. 0.97. What is the ratio of the Rent(as % of GDP) in Sao Tome and Principe in 2005 to that in 2006?
Provide a short and direct response. 1.06. What is the ratio of the Rent(as % of GDP) in Europe(developing only) in 2005 to that in 2007?
Your response must be concise. 1.08. What is the ratio of the Rent(as % of GDP) in Albania in 2005 to that in 2007?
Offer a terse response. 0.74. What is the ratio of the Rent(as % of GDP) of Gambia, The in 2005 to that in 2007?
Offer a terse response. 0.88. What is the ratio of the Rent(as % of GDP) of Sao Tome and Principe in 2005 to that in 2007?
Offer a very short reply. 0.8. What is the ratio of the Rent(as % of GDP) in Europe(developing only) in 2005 to that in 2008?
Ensure brevity in your answer.  1.01. What is the ratio of the Rent(as % of GDP) in Albania in 2005 to that in 2008?
Make the answer very short. 0.68. What is the ratio of the Rent(as % of GDP) in Gambia, The in 2005 to that in 2008?
Your answer should be compact. 0.82. What is the ratio of the Rent(as % of GDP) in Sao Tome and Principe in 2005 to that in 2008?
Your response must be concise. 0.83. What is the ratio of the Rent(as % of GDP) in Europe(developing only) in 2005 to that in 2009?
Keep it short and to the point. 0.93. What is the ratio of the Rent(as % of GDP) in Albania in 2005 to that in 2009?
Keep it short and to the point. 0.52. What is the ratio of the Rent(as % of GDP) of Gambia, The in 2005 to that in 2009?
Your response must be concise. 0.8. What is the ratio of the Rent(as % of GDP) of Sao Tome and Principe in 2005 to that in 2009?
Provide a succinct answer. 0.89. What is the ratio of the Rent(as % of GDP) in Europe(developing only) in 2005 to that in 2010?
Provide a short and direct response. 1. What is the ratio of the Rent(as % of GDP) in Albania in 2005 to that in 2010?
Offer a very short reply. 0.71. What is the ratio of the Rent(as % of GDP) of Gambia, The in 2005 to that in 2010?
Your response must be concise. 0.92. What is the ratio of the Rent(as % of GDP) of Europe(developing only) in 2005 to that in 2011?
Give a very brief answer. 0.93. What is the ratio of the Rent(as % of GDP) in Albania in 2005 to that in 2011?
Keep it short and to the point. 0.21. What is the ratio of the Rent(as % of GDP) of Gambia, The in 2005 to that in 2011?
Your answer should be very brief. 0.78. What is the ratio of the Rent(as % of GDP) of Sao Tome and Principe in 2005 to that in 2011?
Your answer should be compact. 1.11. What is the ratio of the Rent(as % of GDP) of Europe(developing only) in 2006 to that in 2007?
Offer a very short reply. 1.09. What is the ratio of the Rent(as % of GDP) in Albania in 2006 to that in 2007?
Give a very brief answer. 0.78. What is the ratio of the Rent(as % of GDP) in Gambia, The in 2006 to that in 2007?
Make the answer very short. 0.9. What is the ratio of the Rent(as % of GDP) of Sao Tome and Principe in 2006 to that in 2007?
Keep it short and to the point. 0.76. What is the ratio of the Rent(as % of GDP) in Europe(developing only) in 2006 to that in 2008?
Offer a terse response. 1.02. What is the ratio of the Rent(as % of GDP) of Albania in 2006 to that in 2008?
Provide a short and direct response. 0.71. What is the ratio of the Rent(as % of GDP) in Gambia, The in 2006 to that in 2008?
Offer a very short reply. 0.84. What is the ratio of the Rent(as % of GDP) in Sao Tome and Principe in 2006 to that in 2008?
Offer a very short reply. 0.78. What is the ratio of the Rent(as % of GDP) of Europe(developing only) in 2006 to that in 2009?
Give a very brief answer. 0.94. What is the ratio of the Rent(as % of GDP) of Albania in 2006 to that in 2009?
Offer a terse response. 0.55. What is the ratio of the Rent(as % of GDP) of Gambia, The in 2006 to that in 2009?
Your response must be concise. 0.82. What is the ratio of the Rent(as % of GDP) of Sao Tome and Principe in 2006 to that in 2009?
Make the answer very short. 0.84. What is the ratio of the Rent(as % of GDP) in Europe(developing only) in 2006 to that in 2010?
Provide a short and direct response. 1.01. What is the ratio of the Rent(as % of GDP) in Albania in 2006 to that in 2010?
Your answer should be very brief. 0.75. What is the ratio of the Rent(as % of GDP) of Gambia, The in 2006 to that in 2010?
Ensure brevity in your answer.  0.94. What is the ratio of the Rent(as % of GDP) in Sao Tome and Principe in 2006 to that in 2010?
Provide a short and direct response. 0.95. What is the ratio of the Rent(as % of GDP) of Europe(developing only) in 2006 to that in 2011?
Provide a short and direct response. 0.94. What is the ratio of the Rent(as % of GDP) of Albania in 2006 to that in 2011?
Make the answer very short. 0.22. What is the ratio of the Rent(as % of GDP) in Gambia, The in 2006 to that in 2011?
Offer a very short reply. 0.8. What is the ratio of the Rent(as % of GDP) in Sao Tome and Principe in 2006 to that in 2011?
Offer a terse response. 1.05. What is the ratio of the Rent(as % of GDP) of Europe(developing only) in 2007 to that in 2008?
Provide a succinct answer. 0.94. What is the ratio of the Rent(as % of GDP) in Albania in 2007 to that in 2008?
Keep it short and to the point. 0.92. What is the ratio of the Rent(as % of GDP) in Sao Tome and Principe in 2007 to that in 2008?
Your answer should be very brief. 1.03. What is the ratio of the Rent(as % of GDP) in Europe(developing only) in 2007 to that in 2009?
Offer a very short reply. 0.87. What is the ratio of the Rent(as % of GDP) of Albania in 2007 to that in 2009?
Offer a terse response. 0.71. What is the ratio of the Rent(as % of GDP) in Gambia, The in 2007 to that in 2009?
Offer a terse response. 0.91. What is the ratio of the Rent(as % of GDP) in Sao Tome and Principe in 2007 to that in 2009?
Ensure brevity in your answer.  1.11. What is the ratio of the Rent(as % of GDP) in Europe(developing only) in 2007 to that in 2010?
Ensure brevity in your answer.  0.93. What is the ratio of the Rent(as % of GDP) in Gambia, The in 2007 to that in 2010?
Keep it short and to the point. 1.04. What is the ratio of the Rent(as % of GDP) of Sao Tome and Principe in 2007 to that in 2010?
Offer a very short reply. 1.25. What is the ratio of the Rent(as % of GDP) in Europe(developing only) in 2007 to that in 2011?
Ensure brevity in your answer.  0.86. What is the ratio of the Rent(as % of GDP) of Albania in 2007 to that in 2011?
Keep it short and to the point. 0.28. What is the ratio of the Rent(as % of GDP) of Gambia, The in 2007 to that in 2011?
Provide a short and direct response. 0.89. What is the ratio of the Rent(as % of GDP) of Sao Tome and Principe in 2007 to that in 2011?
Ensure brevity in your answer.  1.38. What is the ratio of the Rent(as % of GDP) in Europe(developing only) in 2008 to that in 2009?
Keep it short and to the point. 0.92. What is the ratio of the Rent(as % of GDP) of Albania in 2008 to that in 2009?
Offer a terse response. 0.77. What is the ratio of the Rent(as % of GDP) of Gambia, The in 2008 to that in 2009?
Give a very brief answer. 0.98. What is the ratio of the Rent(as % of GDP) of Sao Tome and Principe in 2008 to that in 2009?
Make the answer very short. 1.08. What is the ratio of the Rent(as % of GDP) of Albania in 2008 to that in 2010?
Your response must be concise. 1.05. What is the ratio of the Rent(as % of GDP) of Gambia, The in 2008 to that in 2010?
Provide a short and direct response. 1.12. What is the ratio of the Rent(as % of GDP) in Sao Tome and Principe in 2008 to that in 2010?
Make the answer very short. 1.21. What is the ratio of the Rent(as % of GDP) of Europe(developing only) in 2008 to that in 2011?
Keep it short and to the point. 0.92. What is the ratio of the Rent(as % of GDP) in Albania in 2008 to that in 2011?
Your answer should be very brief. 0.31. What is the ratio of the Rent(as % of GDP) of Gambia, The in 2008 to that in 2011?
Provide a succinct answer. 0.95. What is the ratio of the Rent(as % of GDP) of Sao Tome and Principe in 2008 to that in 2011?
Offer a terse response. 1.34. What is the ratio of the Rent(as % of GDP) of Europe(developing only) in 2009 to that in 2010?
Make the answer very short. 1.08. What is the ratio of the Rent(as % of GDP) in Albania in 2009 to that in 2010?
Your answer should be very brief. 1.36. What is the ratio of the Rent(as % of GDP) of Gambia, The in 2009 to that in 2010?
Your answer should be compact. 1.14. What is the ratio of the Rent(as % of GDP) of Sao Tome and Principe in 2009 to that in 2010?
Your answer should be very brief. 1.12. What is the ratio of the Rent(as % of GDP) in Albania in 2009 to that in 2011?
Give a very brief answer. 0.4. What is the ratio of the Rent(as % of GDP) in Gambia, The in 2009 to that in 2011?
Offer a very short reply. 0.98. What is the ratio of the Rent(as % of GDP) in Sao Tome and Principe in 2009 to that in 2011?
Provide a short and direct response. 1.24. What is the ratio of the Rent(as % of GDP) of Europe(developing only) in 2010 to that in 2011?
Provide a succinct answer. 0.92. What is the ratio of the Rent(as % of GDP) of Albania in 2010 to that in 2011?
Offer a very short reply. 0.29. What is the ratio of the Rent(as % of GDP) of Gambia, The in 2010 to that in 2011?
Provide a succinct answer. 0.85. What is the ratio of the Rent(as % of GDP) in Sao Tome and Principe in 2010 to that in 2011?
Provide a succinct answer. 1.11. What is the difference between the highest and the second highest Rent(as % of GDP) of Europe(developing only)?
Provide a succinct answer. 0. What is the difference between the highest and the second highest Rent(as % of GDP) of Albania?
Make the answer very short. 0.19. What is the difference between the highest and the second highest Rent(as % of GDP) in Gambia, The?
Provide a succinct answer. 0.13. What is the difference between the highest and the second highest Rent(as % of GDP) of Sao Tome and Principe?
Your response must be concise. 0.11. What is the difference between the highest and the lowest Rent(as % of GDP) of Europe(developing only)?
Provide a short and direct response. 0.03. What is the difference between the highest and the lowest Rent(as % of GDP) in Albania?
Provide a succinct answer. 0.25. What is the difference between the highest and the lowest Rent(as % of GDP) in Gambia, The?
Offer a very short reply. 1.19. What is the difference between the highest and the lowest Rent(as % of GDP) in Sao Tome and Principe?
Give a very brief answer. 1.03. 